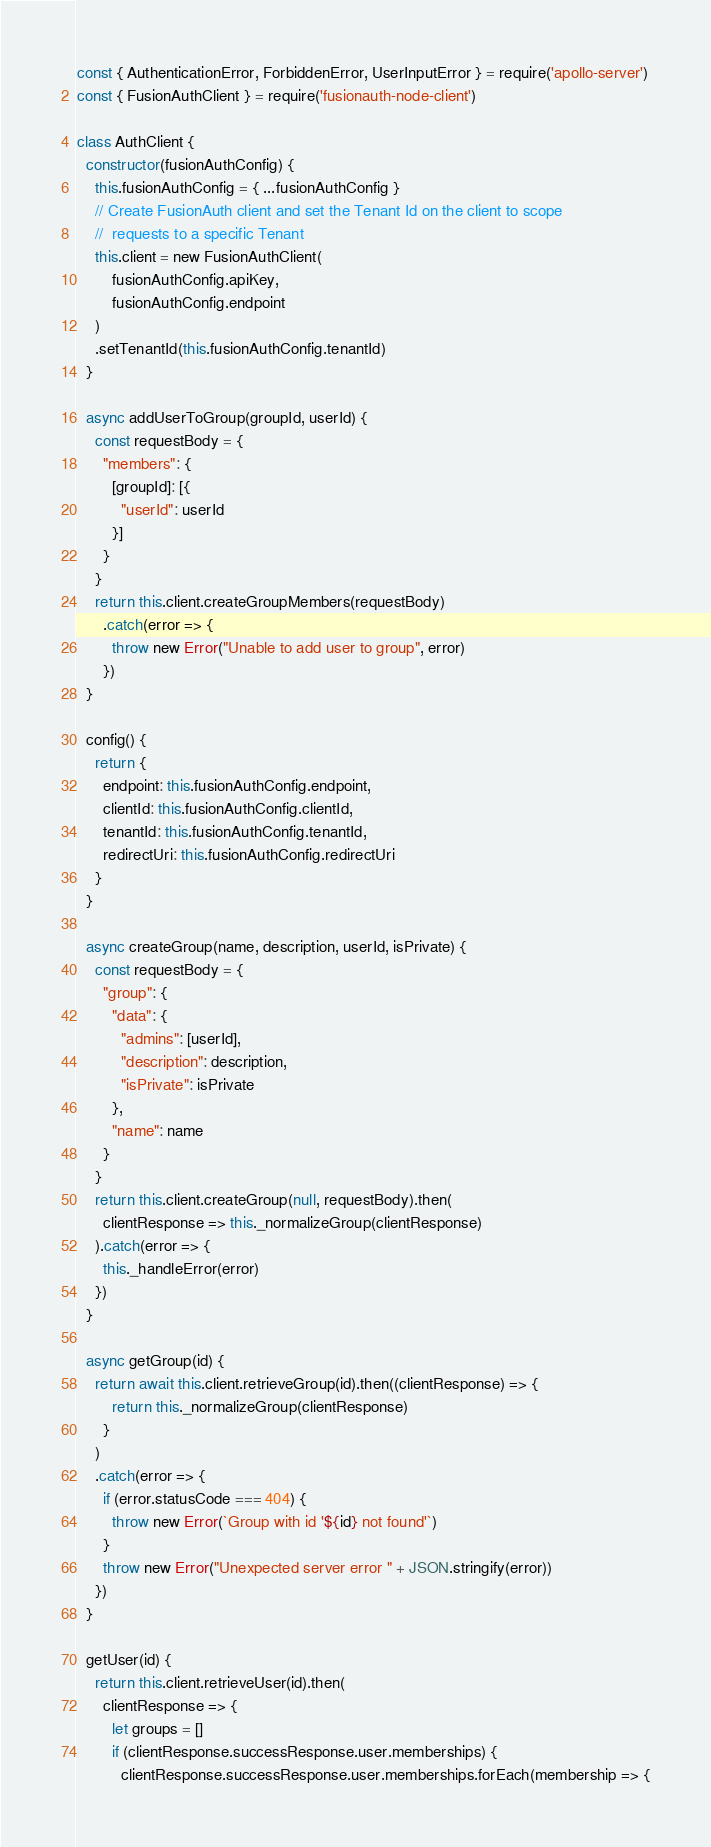Convert code to text. <code><loc_0><loc_0><loc_500><loc_500><_JavaScript_>const { AuthenticationError, ForbiddenError, UserInputError } = require('apollo-server')
const { FusionAuthClient } = require('fusionauth-node-client')

class AuthClient {
  constructor(fusionAuthConfig) {
    this.fusionAuthConfig = { ...fusionAuthConfig }
    // Create FusionAuth client and set the Tenant Id on the client to scope
    //  requests to a specific Tenant
    this.client = new FusionAuthClient(
        fusionAuthConfig.apiKey,
        fusionAuthConfig.endpoint
    )
    .setTenantId(this.fusionAuthConfig.tenantId)
  }

  async addUserToGroup(groupId, userId) {
    const requestBody = {
      "members": {
        [groupId]: [{
          "userId": userId
        }]
      }
    }
    return this.client.createGroupMembers(requestBody)
      .catch(error => {
        throw new Error("Unable to add user to group", error)
      })
  }

  config() {
    return {
      endpoint: this.fusionAuthConfig.endpoint,
      clientId: this.fusionAuthConfig.clientId,
      tenantId: this.fusionAuthConfig.tenantId,
      redirectUri: this.fusionAuthConfig.redirectUri
    }
  }

  async createGroup(name, description, userId, isPrivate) {
    const requestBody = {
      "group": {
        "data": {
          "admins": [userId],
          "description": description,
          "isPrivate": isPrivate
        },
        "name": name
      }
    }
    return this.client.createGroup(null, requestBody).then(
      clientResponse => this._normalizeGroup(clientResponse)
    ).catch(error => {
      this._handleError(error)
    })
  }

  async getGroup(id) {
    return await this.client.retrieveGroup(id).then((clientResponse) => {
        return this._normalizeGroup(clientResponse)
      }
    )
    .catch(error => {
      if (error.statusCode === 404) {
        throw new Error(`Group with id '${id} not found'`)
      }
      throw new Error("Unexpected server error " + JSON.stringify(error))
    })
  }

  getUser(id) {
    return this.client.retrieveUser(id).then(
      clientResponse => {
        let groups = []
        if (clientResponse.successResponse.user.memberships) {
          clientResponse.successResponse.user.memberships.forEach(membership => {</code> 